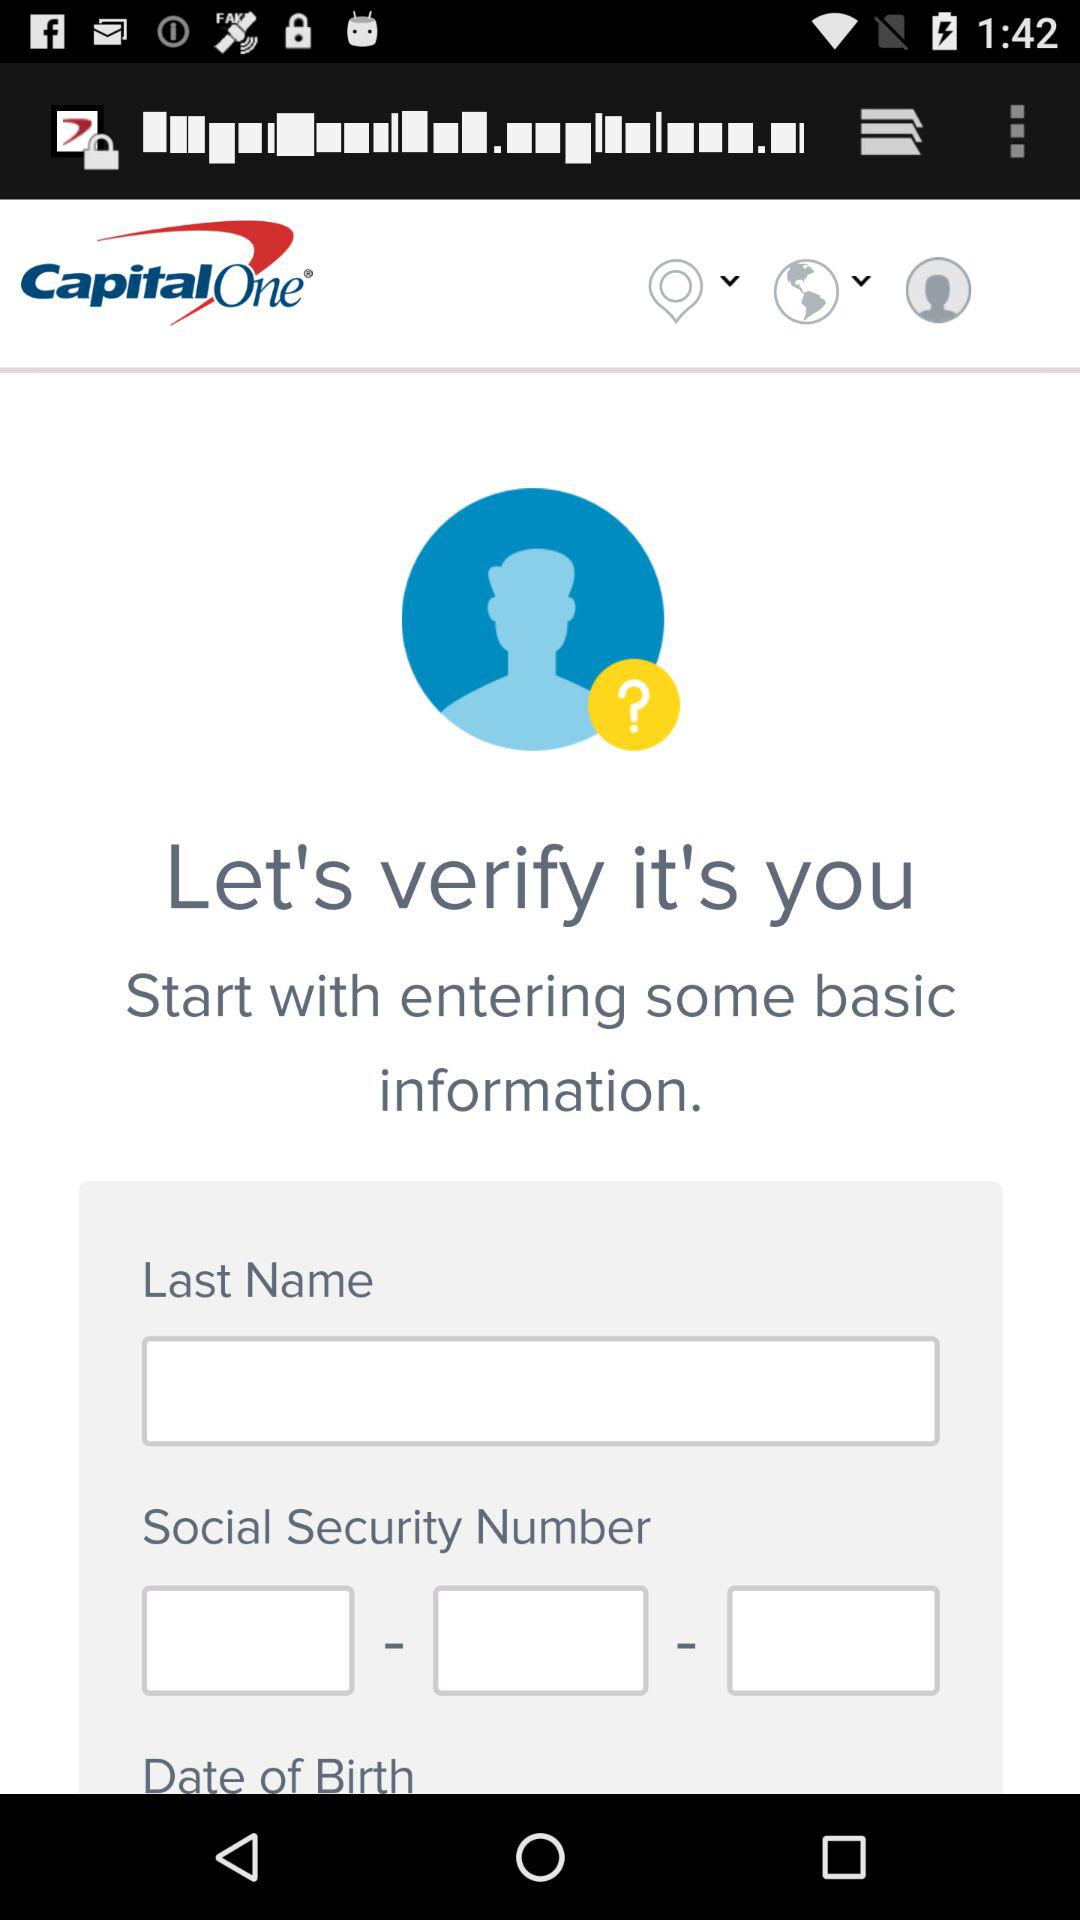What is the application name? The application name is "Capital One Mobile". 